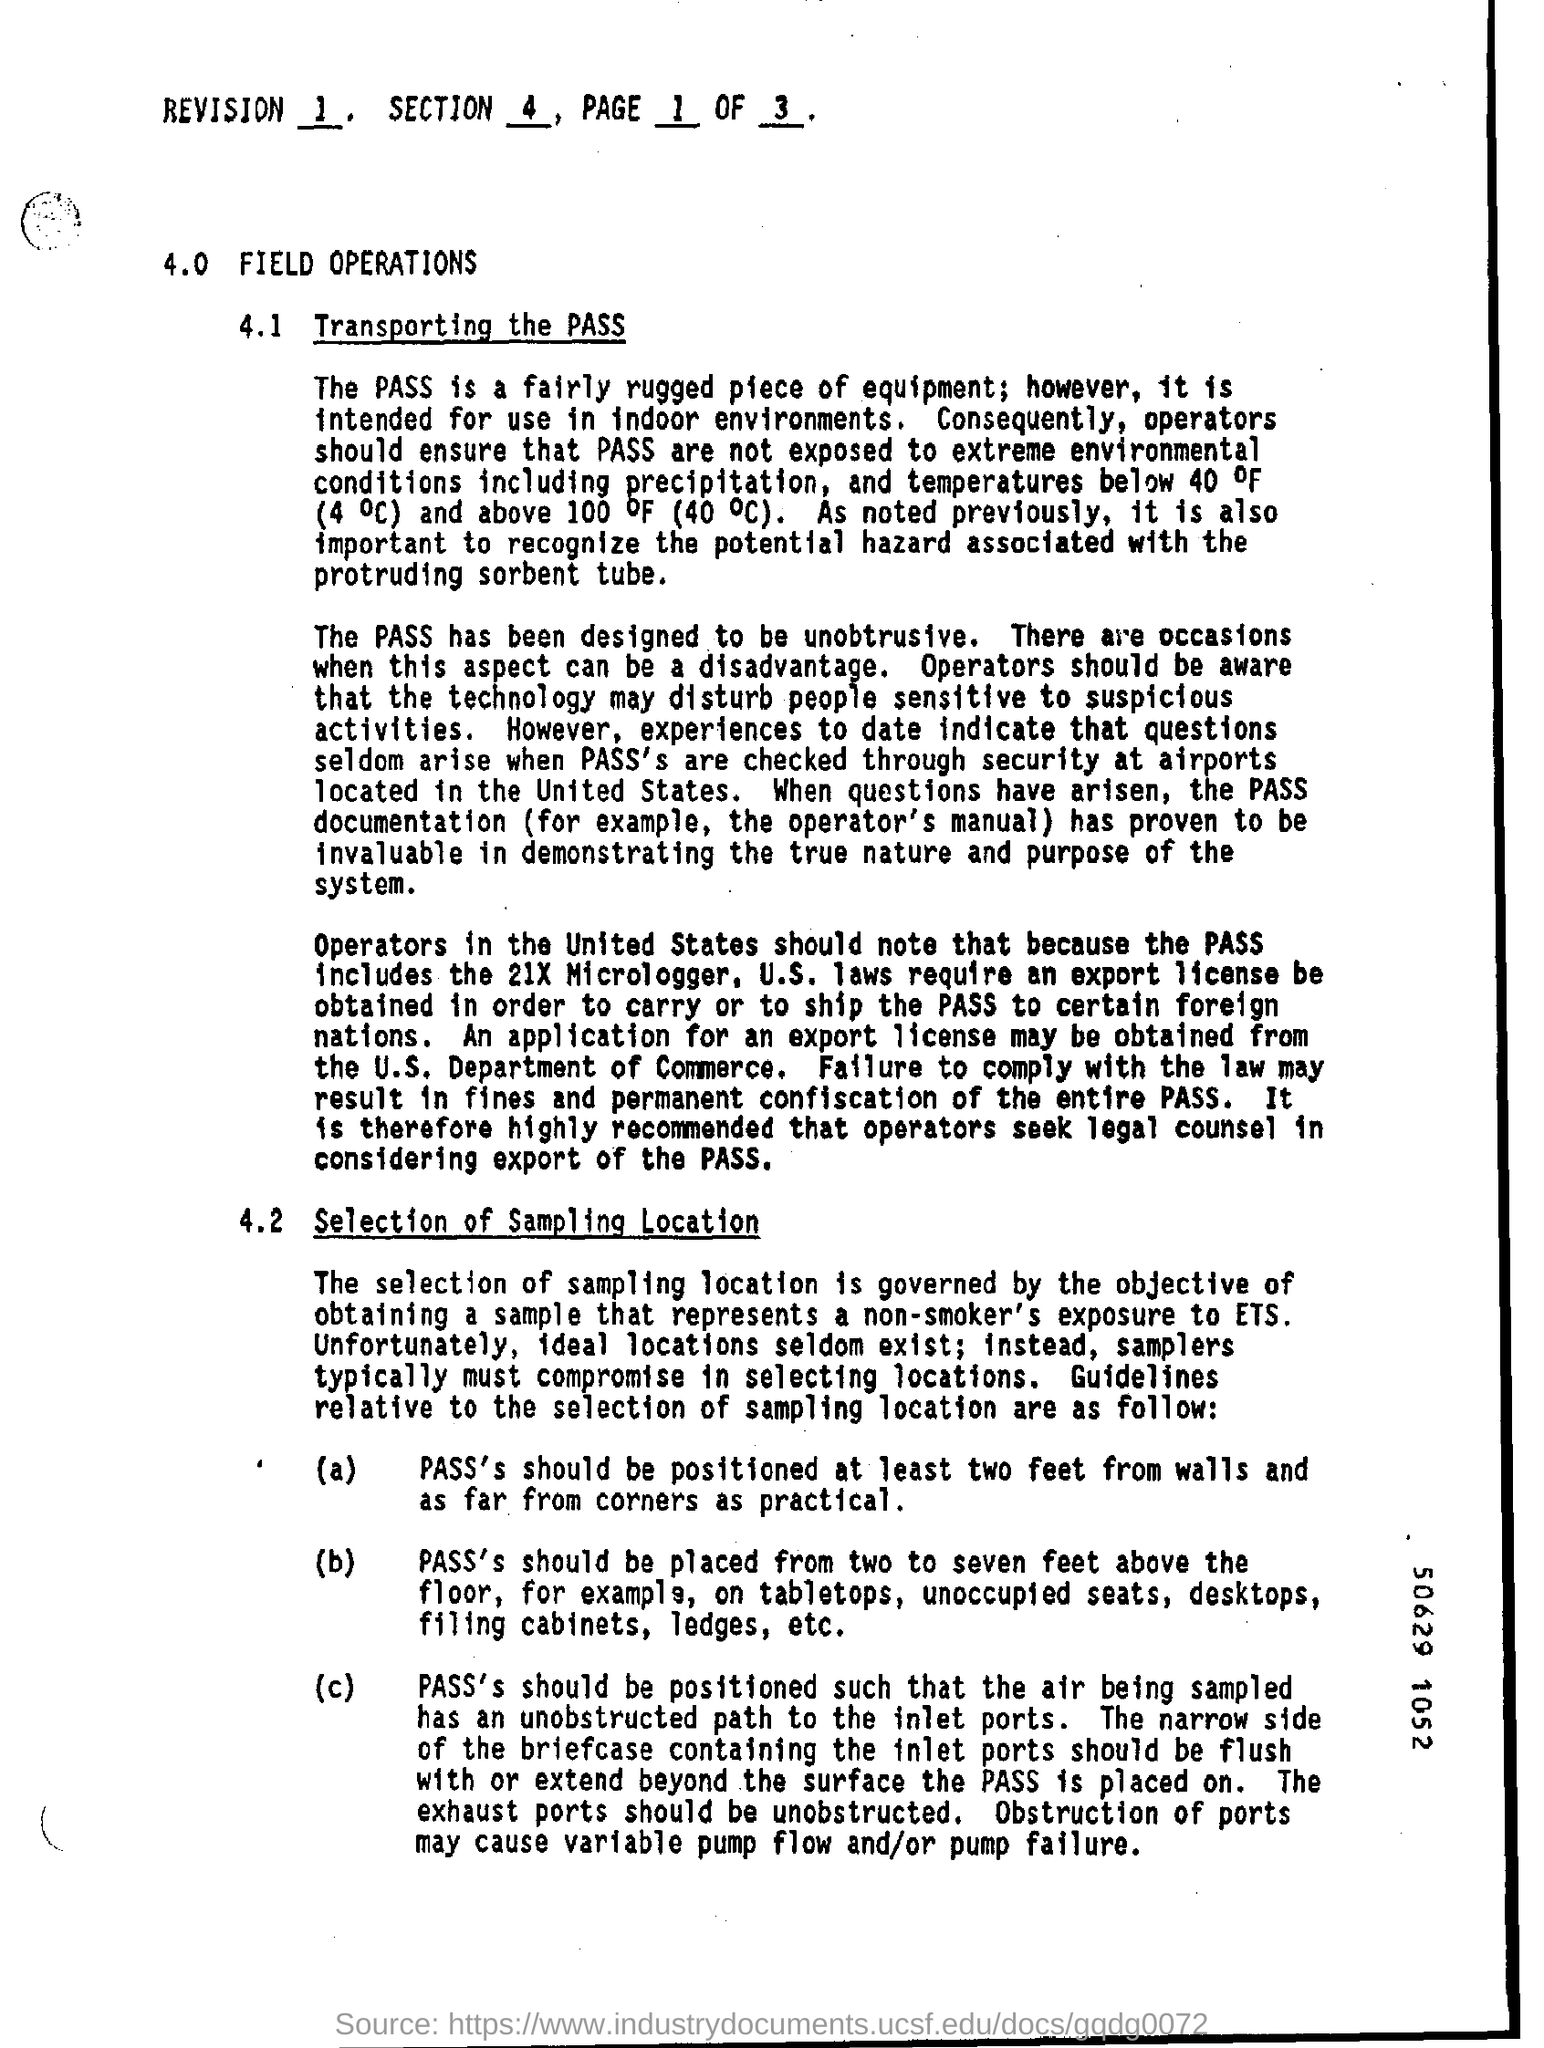What is the "REVISION" number given at the top of the page?
Provide a succinct answer. 1. What is the "SECTION" number given at the top of the page?
Offer a terse response. 4. What is the "PAGE" number given at the top of the page?
Keep it short and to the point. 1. What is the side heading given at 4.0?
Provide a short and direct response. FIELD OPERATIONS. What is the sub heading given at 4.1?
Your answer should be compact. Transporting the PASS. What has been designed to be unobstrusive?
Provide a short and direct response. THE PASS. An application for an export licence may be obtained from which department?
Ensure brevity in your answer.  The U.S. department of commerce. What is the sub heading given at 4.2?
Provide a succinct answer. Selection of Sampling Location. 